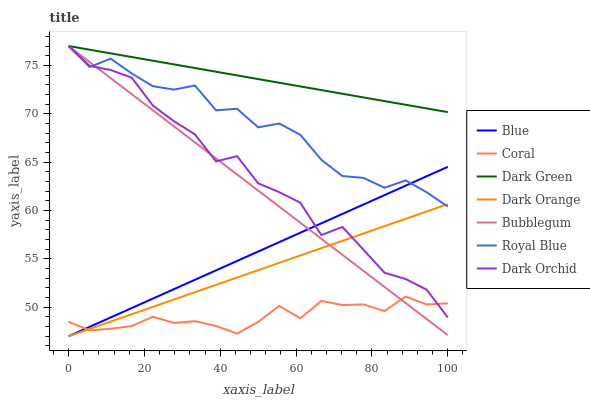Does Coral have the minimum area under the curve?
Answer yes or no. Yes. Does Dark Green have the maximum area under the curve?
Answer yes or no. Yes. Does Dark Orange have the minimum area under the curve?
Answer yes or no. No. Does Dark Orange have the maximum area under the curve?
Answer yes or no. No. Is Blue the smoothest?
Answer yes or no. Yes. Is Dark Orchid the roughest?
Answer yes or no. Yes. Is Dark Orange the smoothest?
Answer yes or no. No. Is Dark Orange the roughest?
Answer yes or no. No. Does Blue have the lowest value?
Answer yes or no. Yes. Does Coral have the lowest value?
Answer yes or no. No. Does Dark Green have the highest value?
Answer yes or no. Yes. Does Dark Orange have the highest value?
Answer yes or no. No. Is Blue less than Dark Green?
Answer yes or no. Yes. Is Dark Green greater than Dark Orange?
Answer yes or no. Yes. Does Bubblegum intersect Blue?
Answer yes or no. Yes. Is Bubblegum less than Blue?
Answer yes or no. No. Is Bubblegum greater than Blue?
Answer yes or no. No. Does Blue intersect Dark Green?
Answer yes or no. No. 